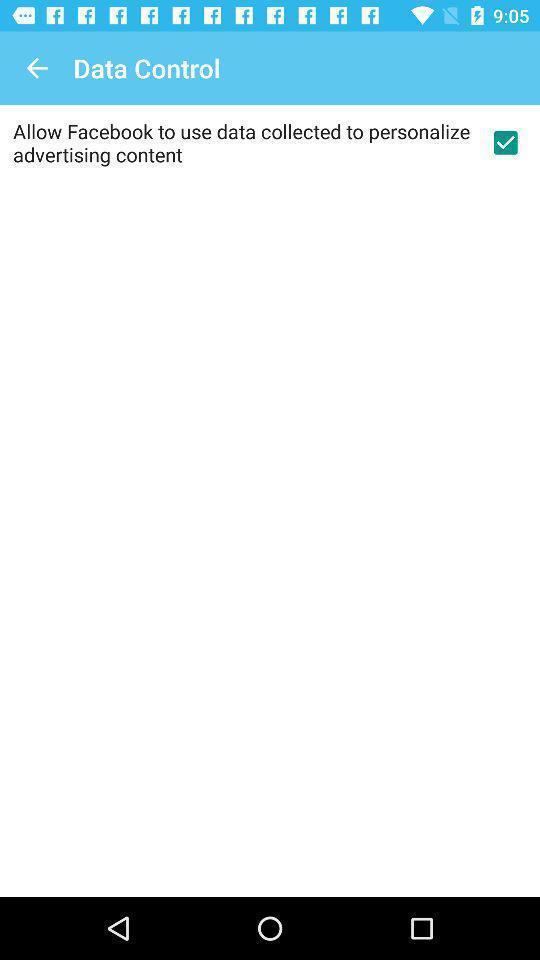Summarize the information in this screenshot. Page shows data control and some information. 